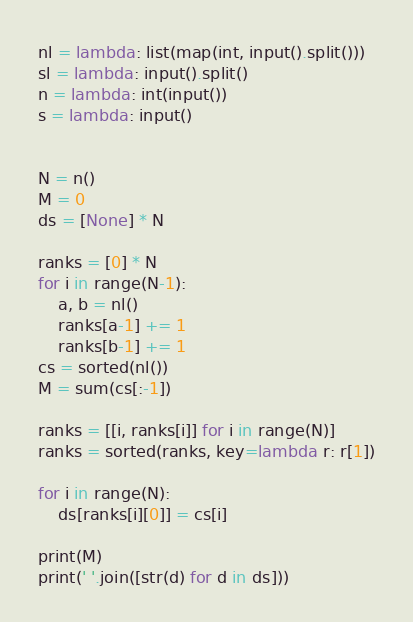<code> <loc_0><loc_0><loc_500><loc_500><_Python_>
nl = lambda: list(map(int, input().split()))
sl = lambda: input().split()
n = lambda: int(input())
s = lambda: input()


N = n()
M = 0
ds = [None] * N

ranks = [0] * N
for i in range(N-1):
    a, b = nl()
    ranks[a-1] += 1
    ranks[b-1] += 1
cs = sorted(nl())
M = sum(cs[:-1])

ranks = [[i, ranks[i]] for i in range(N)]
ranks = sorted(ranks, key=lambda r: r[1])

for i in range(N):
    ds[ranks[i][0]] = cs[i]

print(M)
print(' '.join([str(d) for d in ds]))
</code> 